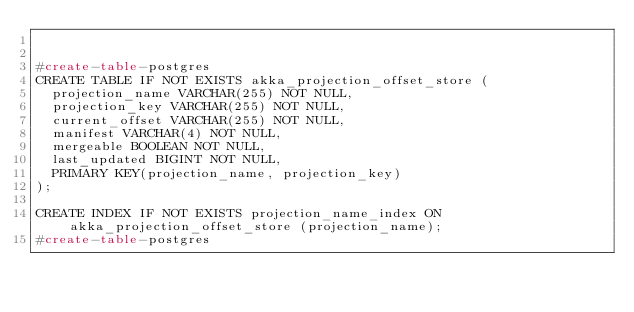Convert code to text. <code><loc_0><loc_0><loc_500><loc_500><_SQL_>

#create-table-postgres
CREATE TABLE IF NOT EXISTS akka_projection_offset_store (
  projection_name VARCHAR(255) NOT NULL,
  projection_key VARCHAR(255) NOT NULL,
  current_offset VARCHAR(255) NOT NULL,
  manifest VARCHAR(4) NOT NULL,
  mergeable BOOLEAN NOT NULL,
  last_updated BIGINT NOT NULL,
  PRIMARY KEY(projection_name, projection_key)
);

CREATE INDEX IF NOT EXISTS projection_name_index ON akka_projection_offset_store (projection_name);
#create-table-postgres</code> 